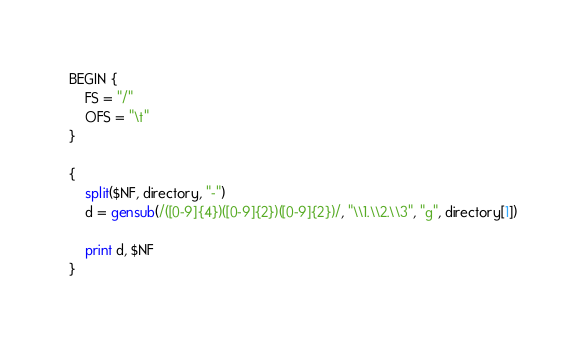Convert code to text. <code><loc_0><loc_0><loc_500><loc_500><_Awk_>BEGIN {
    FS = "/"
    OFS = "\t"
}

{
    split($NF, directory, "-")
    d = gensub(/([0-9]{4})([0-9]{2})([0-9]{2})/, "\\1.\\2.\\3", "g", directory[1])

    print d, $NF
}
</code> 